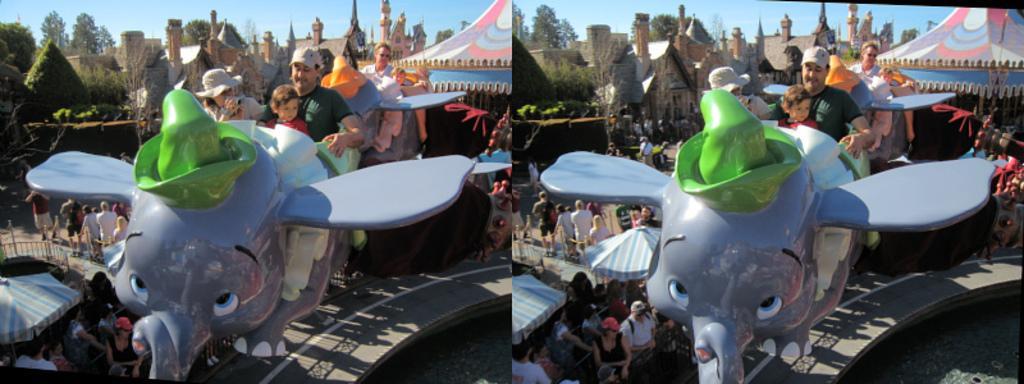Can you describe this image briefly? This is an edited image. This picture is the collage of two images. In this picture, We see the people are riding the carousel. In the left bottom, we see the people are standing under a tent. Behind them, we see the railing and beside that, we see the people are standing. In the right top, we see a tent in white, red and blue color. There are trees and the buildings in the background. At the top, we see the sky. This image is same as the image which is on the right side. 